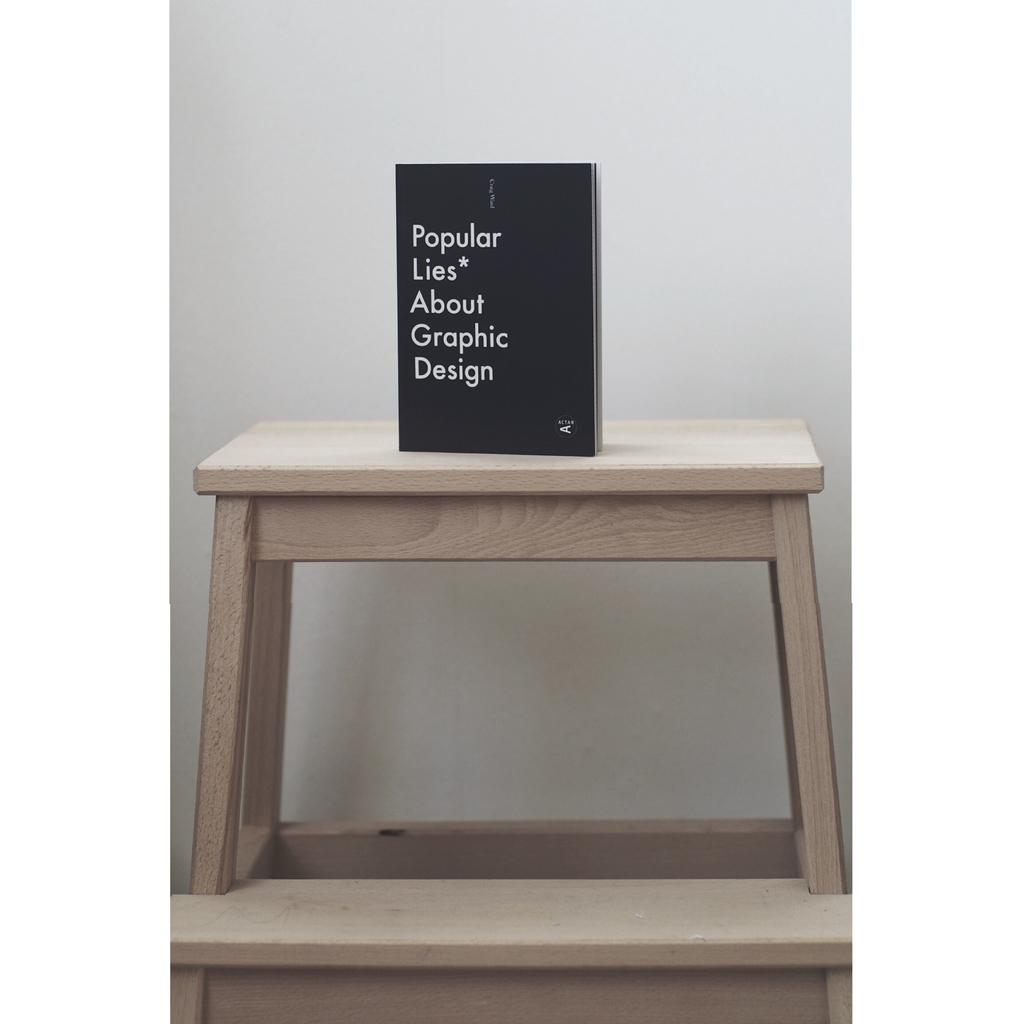What object is placed on the table in the image? There is a book on the table in the image. What can be found on the book? There is text on the book. What color is the background of the image? The background of the image is white in color. What type of vest can be seen hanging on the wall in the image? There is no vest present in the image; it only features a book on a table with a white background. What color is the paint used on the bell in the image? There is no bell present in the image, so it is not possible to determine the color of any paint used on it. 